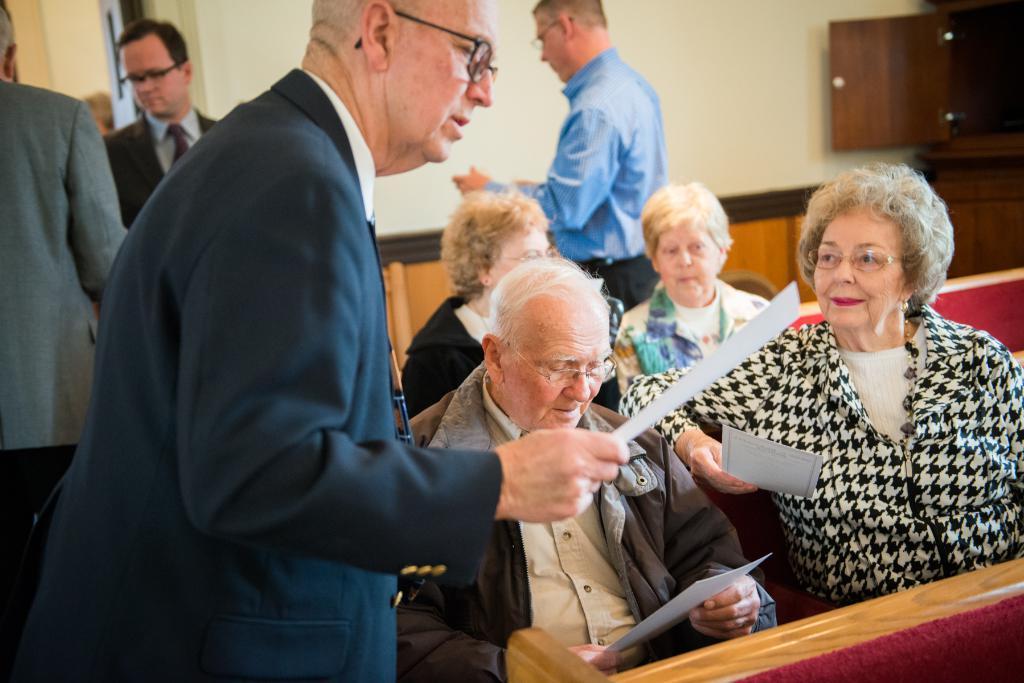Please provide a concise description of this image. Few people are sitting and few people are standing and these three people are holding papers and we can see sofas. In the background we can see wall and cupboard. 